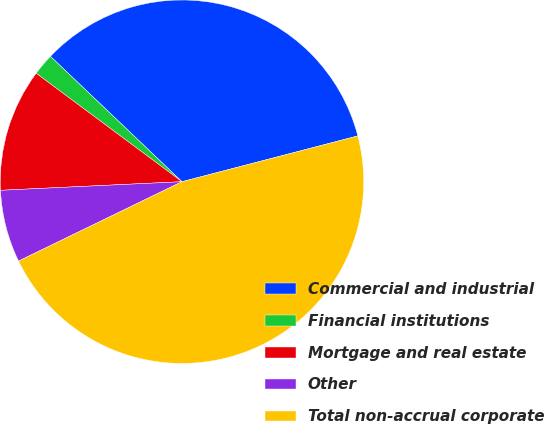<chart> <loc_0><loc_0><loc_500><loc_500><pie_chart><fcel>Commercial and industrial<fcel>Financial institutions<fcel>Mortgage and real estate<fcel>Other<fcel>Total non-accrual corporate<nl><fcel>33.83%<fcel>1.94%<fcel>10.93%<fcel>6.44%<fcel>46.86%<nl></chart> 